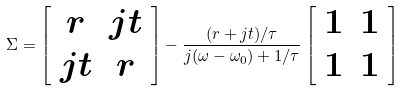Convert formula to latex. <formula><loc_0><loc_0><loc_500><loc_500>\Sigma = \left [ \begin{array} { c c } r & j t \\ j t & r \end{array} \right ] - \frac { ( r + j t ) / \tau } { j ( \omega - \omega _ { 0 } ) + 1 / \tau } \left [ \begin{array} { c c } 1 & 1 \\ 1 & 1 \end{array} \right ]</formula> 